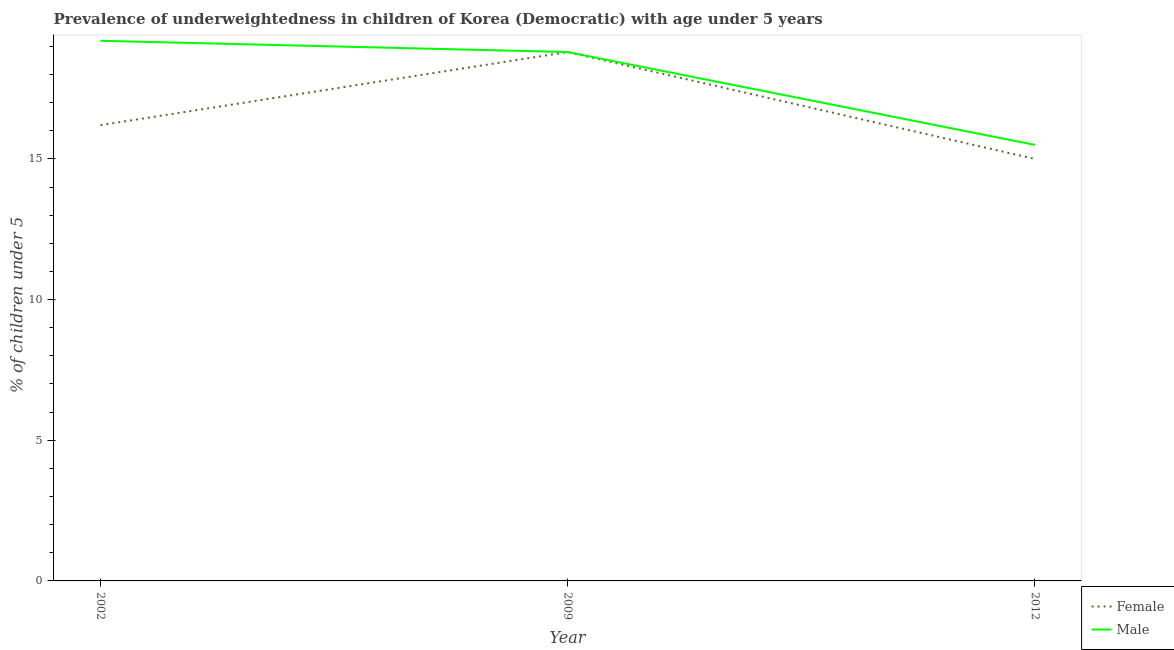How many different coloured lines are there?
Ensure brevity in your answer.  2. Does the line corresponding to percentage of underweighted female children intersect with the line corresponding to percentage of underweighted male children?
Ensure brevity in your answer.  Yes. What is the percentage of underweighted male children in 2009?
Make the answer very short. 18.8. Across all years, what is the maximum percentage of underweighted female children?
Ensure brevity in your answer.  18.8. In which year was the percentage of underweighted female children minimum?
Your answer should be compact. 2012. What is the total percentage of underweighted male children in the graph?
Make the answer very short. 53.5. What is the difference between the percentage of underweighted male children in 2009 and that in 2012?
Provide a succinct answer. 3.3. What is the difference between the percentage of underweighted female children in 2009 and the percentage of underweighted male children in 2012?
Your response must be concise. 3.3. What is the average percentage of underweighted male children per year?
Offer a terse response. 17.83. In the year 2009, what is the difference between the percentage of underweighted female children and percentage of underweighted male children?
Offer a very short reply. 0. In how many years, is the percentage of underweighted female children greater than 15 %?
Your answer should be very brief. 2. What is the ratio of the percentage of underweighted male children in 2009 to that in 2012?
Make the answer very short. 1.21. Is the percentage of underweighted male children in 2009 less than that in 2012?
Your answer should be very brief. No. What is the difference between the highest and the second highest percentage of underweighted male children?
Make the answer very short. 0.4. What is the difference between the highest and the lowest percentage of underweighted female children?
Your response must be concise. 3.8. Is the sum of the percentage of underweighted female children in 2009 and 2012 greater than the maximum percentage of underweighted male children across all years?
Provide a short and direct response. Yes. Does the percentage of underweighted male children monotonically increase over the years?
Give a very brief answer. No. How many years are there in the graph?
Provide a short and direct response. 3. Are the values on the major ticks of Y-axis written in scientific E-notation?
Your answer should be very brief. No. Does the graph contain grids?
Ensure brevity in your answer.  No. How many legend labels are there?
Your answer should be very brief. 2. How are the legend labels stacked?
Your answer should be very brief. Vertical. What is the title of the graph?
Ensure brevity in your answer.  Prevalence of underweightedness in children of Korea (Democratic) with age under 5 years. Does "Investments" appear as one of the legend labels in the graph?
Keep it short and to the point. No. What is the label or title of the Y-axis?
Keep it short and to the point.  % of children under 5. What is the  % of children under 5 in Female in 2002?
Offer a terse response. 16.2. What is the  % of children under 5 in Male in 2002?
Keep it short and to the point. 19.2. What is the  % of children under 5 in Female in 2009?
Ensure brevity in your answer.  18.8. What is the  % of children under 5 of Male in 2009?
Your answer should be very brief. 18.8. Across all years, what is the maximum  % of children under 5 in Female?
Ensure brevity in your answer.  18.8. Across all years, what is the maximum  % of children under 5 of Male?
Your response must be concise. 19.2. What is the total  % of children under 5 in Male in the graph?
Make the answer very short. 53.5. What is the difference between the  % of children under 5 of Female in 2002 and that in 2009?
Make the answer very short. -2.6. What is the difference between the  % of children under 5 in Female in 2002 and that in 2012?
Your answer should be compact. 1.2. What is the difference between the  % of children under 5 in Female in 2002 and the  % of children under 5 in Male in 2012?
Provide a short and direct response. 0.7. What is the average  % of children under 5 in Female per year?
Give a very brief answer. 16.67. What is the average  % of children under 5 of Male per year?
Offer a very short reply. 17.83. In the year 2009, what is the difference between the  % of children under 5 in Female and  % of children under 5 in Male?
Keep it short and to the point. 0. What is the ratio of the  % of children under 5 of Female in 2002 to that in 2009?
Offer a terse response. 0.86. What is the ratio of the  % of children under 5 in Male in 2002 to that in 2009?
Offer a terse response. 1.02. What is the ratio of the  % of children under 5 in Female in 2002 to that in 2012?
Your answer should be compact. 1.08. What is the ratio of the  % of children under 5 in Male in 2002 to that in 2012?
Offer a very short reply. 1.24. What is the ratio of the  % of children under 5 of Female in 2009 to that in 2012?
Make the answer very short. 1.25. What is the ratio of the  % of children under 5 of Male in 2009 to that in 2012?
Offer a very short reply. 1.21. What is the difference between the highest and the lowest  % of children under 5 of Male?
Keep it short and to the point. 3.7. 